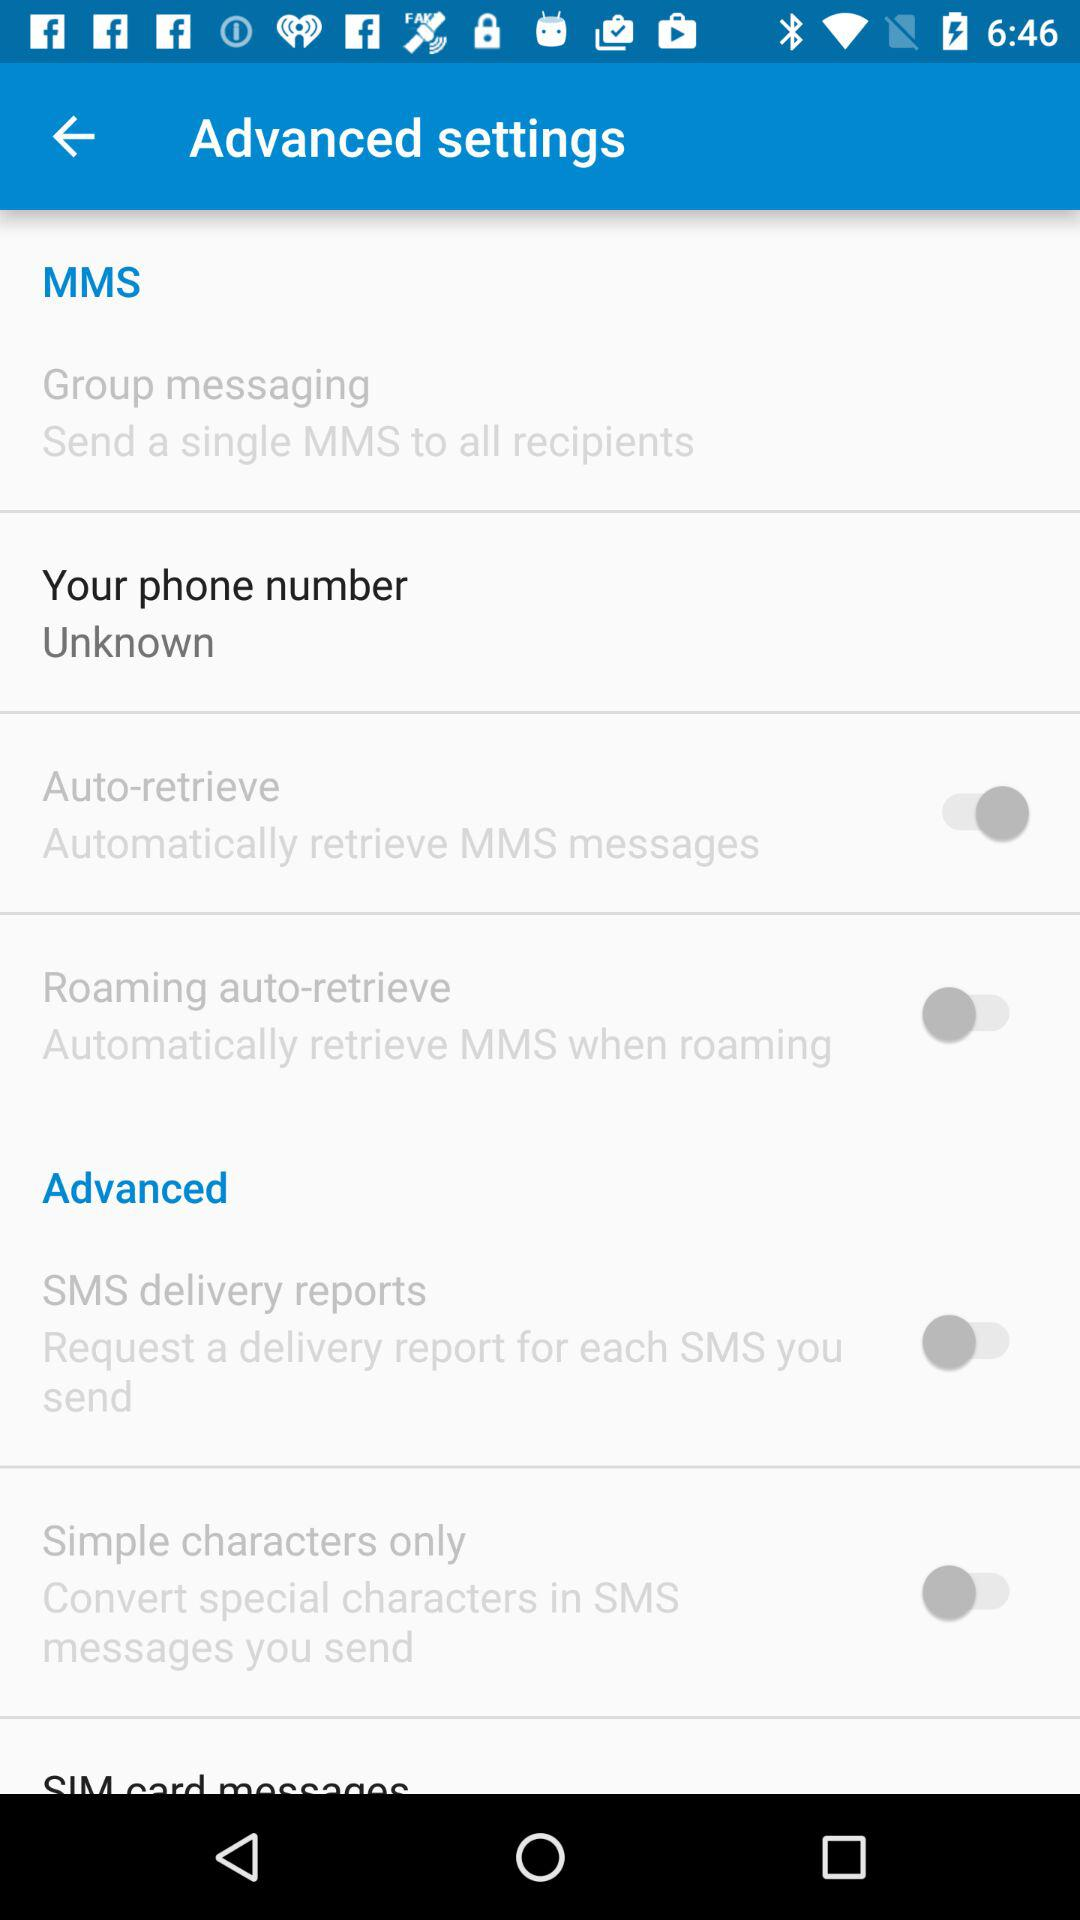What is the status of the "Roaming auto-retrieve"? The status of the "Roaming auto-retrieve" is "off". 